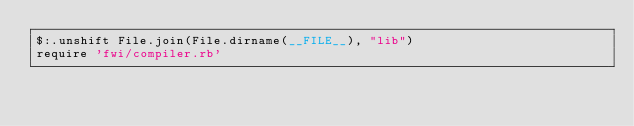<code> <loc_0><loc_0><loc_500><loc_500><_Ruby_>$:.unshift File.join(File.dirname(__FILE__), "lib")
require 'fwi/compiler.rb'</code> 